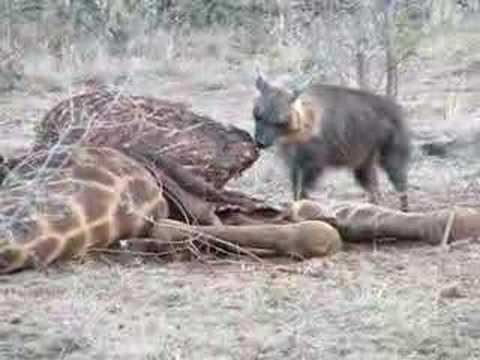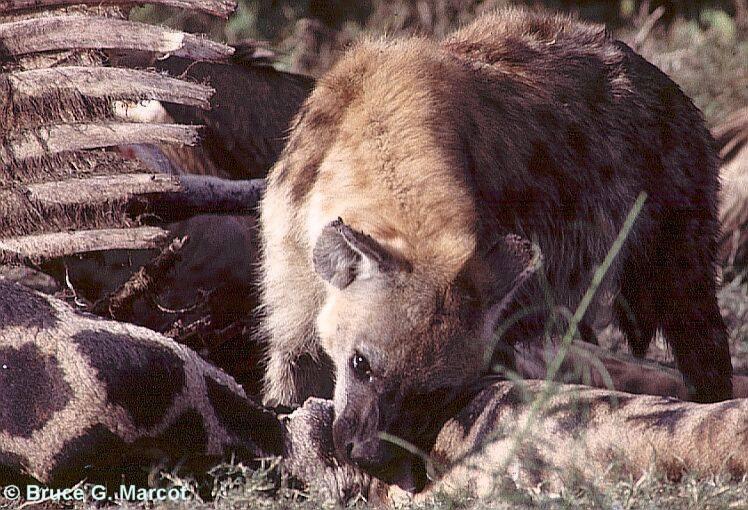The first image is the image on the left, the second image is the image on the right. Analyze the images presented: Is the assertion "There are three brown and spotted hyenas  eat the carcass of a giraffe ." valid? Answer yes or no. No. The first image is the image on the left, the second image is the image on the right. Analyze the images presented: Is the assertion "Each image includes the carcass of a giraffe with at least some of its distinctively patterned hide intact, and the right image features a hyena with its head bent to the carcass." valid? Answer yes or no. Yes. 